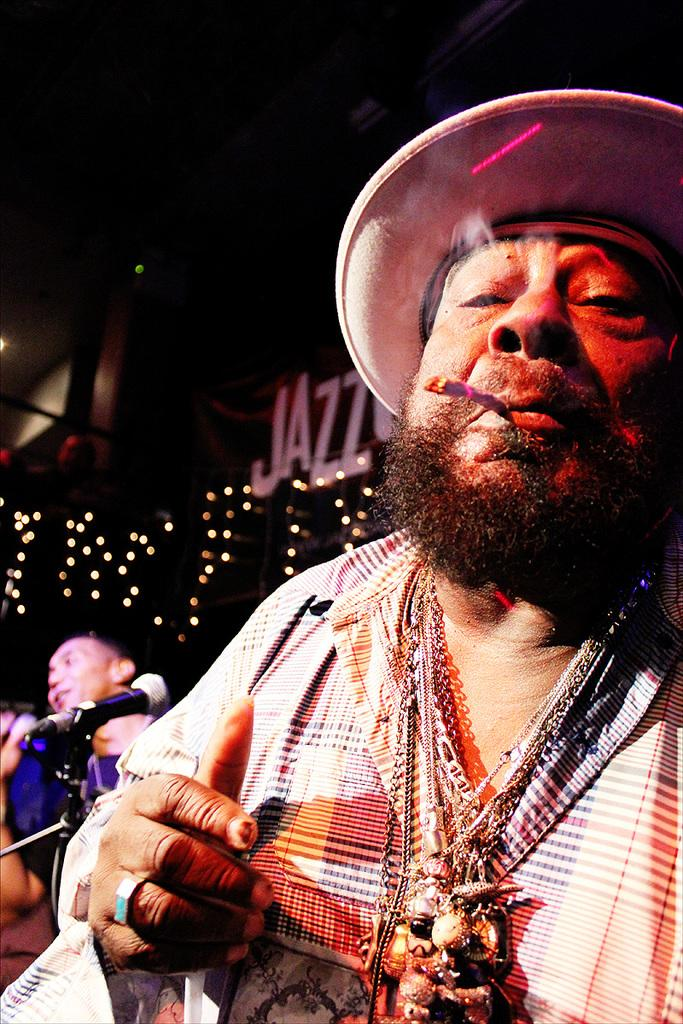What is the person in the front of the image wearing? The person in the front of the image is wearing a hat. Can you describe the person behind the person wearing a hat? There is another person behind the person wearing a hat. What equipment is visible in the image? There is a microphone and a stand in the image. What can be seen in the background of the image? There are lights in the background of the image. What type of moon can be seen in the image? There is no moon present in the image. How does the person in the front of the image shake hands with the person behind them? The image does not show the two people shaking hands, so it cannot be determined from the image. 